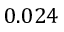<formula> <loc_0><loc_0><loc_500><loc_500>0 . 0 2 4</formula> 